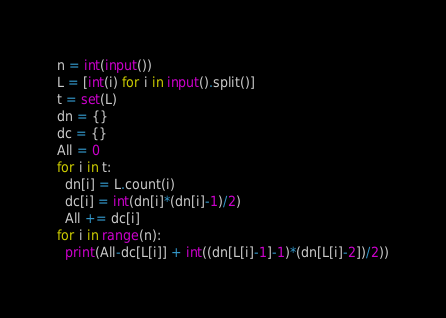Convert code to text. <code><loc_0><loc_0><loc_500><loc_500><_Python_>n = int(input())
L = [int(i) for i in input().split()]
t = set(L)
dn = {}
dc = {}
All = 0
for i in t:
  dn[i] = L.count(i)
  dc[i] = int(dn[i]*(dn[i]-1)/2)
  All += dc[i]
for i in range(n):
  print(All-dc[L[i]] + int((dn[L[i]-1]-1)*(dn[L[i]-2])/2))</code> 